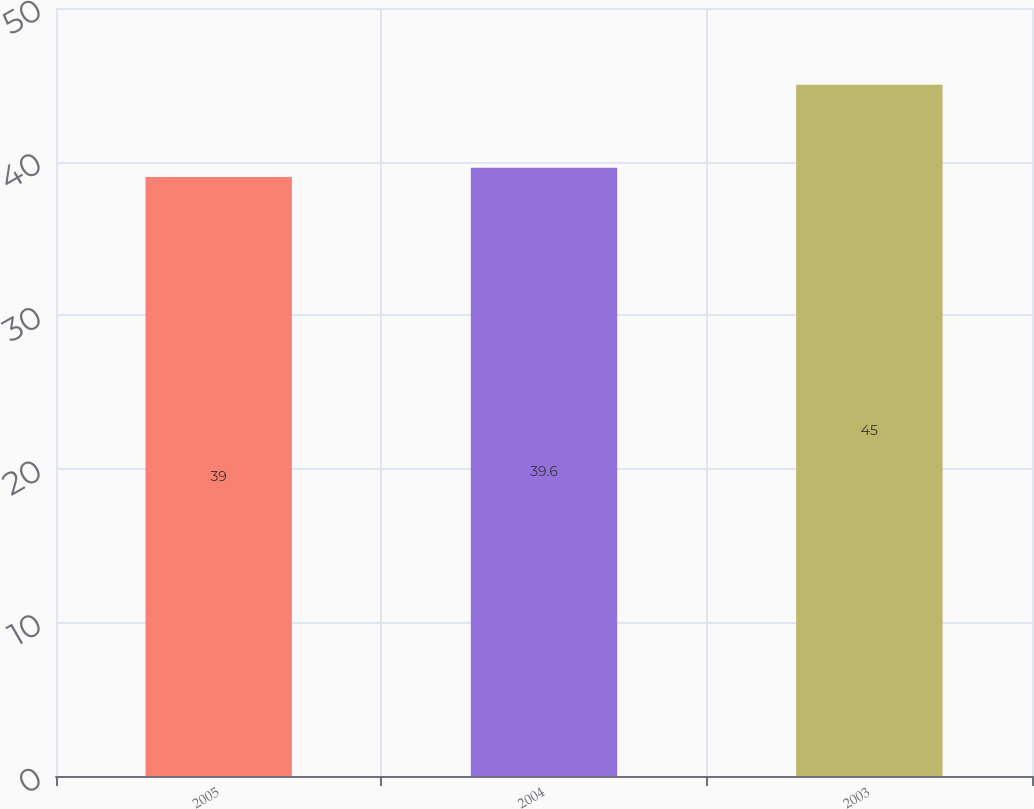Convert chart. <chart><loc_0><loc_0><loc_500><loc_500><bar_chart><fcel>2005<fcel>2004<fcel>2003<nl><fcel>39<fcel>39.6<fcel>45<nl></chart> 